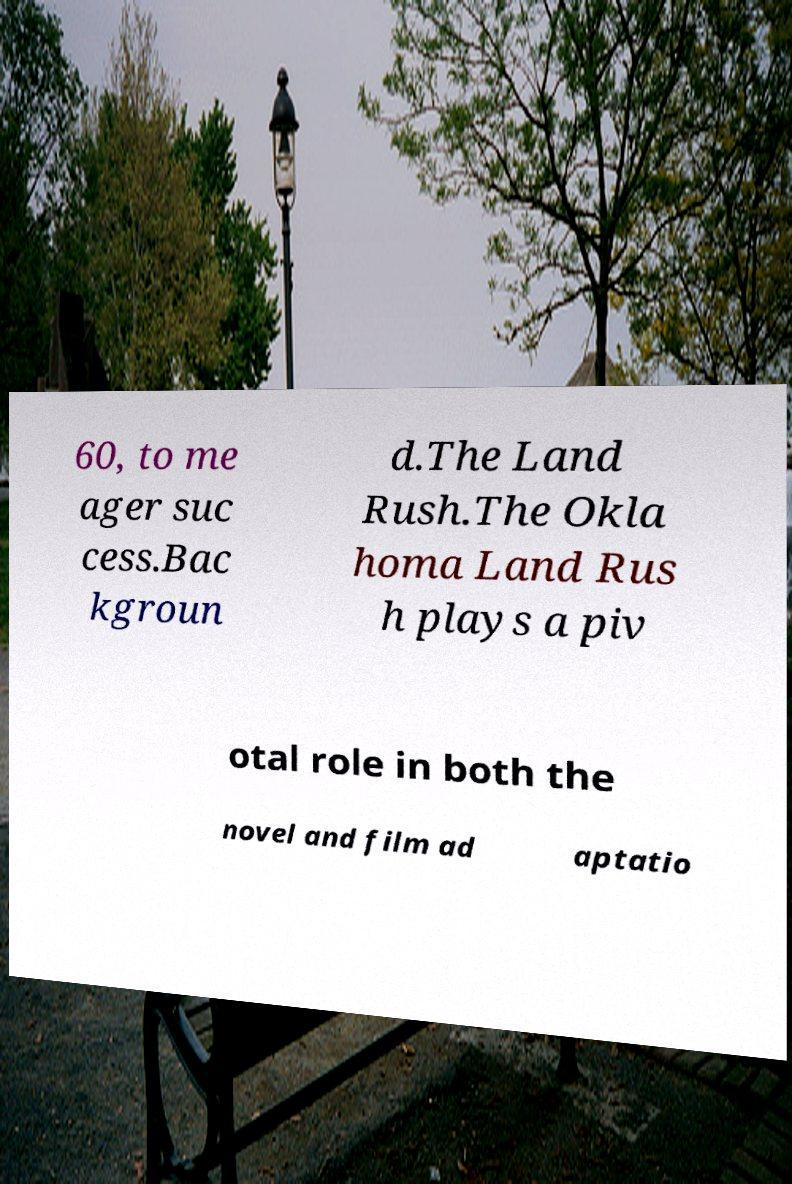There's text embedded in this image that I need extracted. Can you transcribe it verbatim? 60, to me ager suc cess.Bac kgroun d.The Land Rush.The Okla homa Land Rus h plays a piv otal role in both the novel and film ad aptatio 